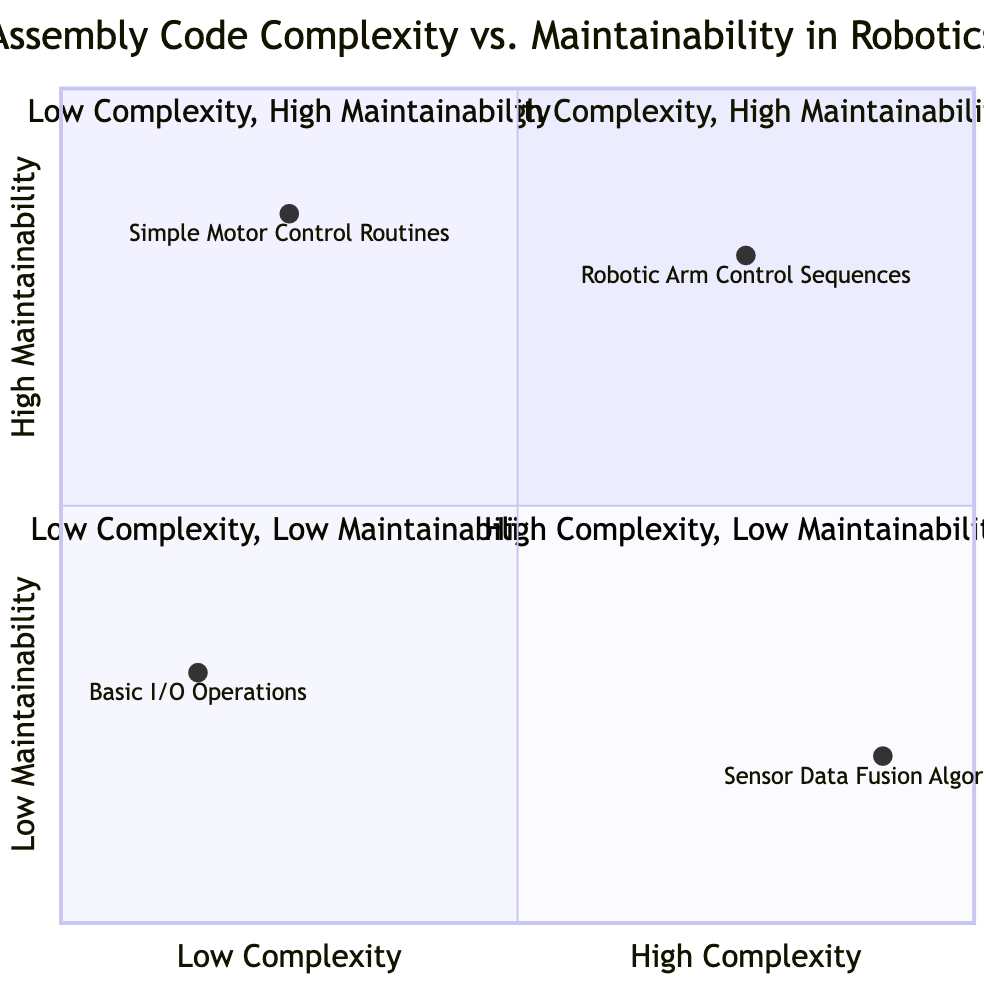What is the element in the High Complexity - High Maintainability quadrant? In the diagram, the High Complexity - High Maintainability quadrant lists "Robotic Arm Control Sequences" as the only element.
Answer: Robotic Arm Control Sequences How many elements are in the Low Complexity - Low Maintainability quadrant? The diagram shows that there is one element listed in the Low Complexity - Low Maintainability quadrant, which is "Basic I/O Operations."
Answer: One Which element has the highest complexity rating? From the diagram, the "Sensor Data Fusion Algorithms" is positioned in the High Complexity - Low Maintainability quadrant, representing the highest complexity.
Answer: Sensor Data Fusion Algorithms What is the maintainability rating of "Simple Motor Control Routines"? In the diagram, "Simple Motor Control Routines" is located in the Low Complexity - High Maintainability quadrant, indicating that it has a maintainability rating of 0.85.
Answer: 0.85 How does the maintainability of "Robotic Arm Control Sequences" compare to "Sensor Data Fusion Algorithms"? The maintainability rating of "Robotic Arm Control Sequences" is 0.80, while "Sensor Data Fusion Algorithms" has a maintainability rating of 0.20. This indicates that "Robotic Arm Control Sequences" is significantly more maintainable than "Sensor Data Fusion Algorithms."
Answer: Higher What element has the lowest maintainability rating? According to the data presented in the diagram, "Basic I/O Operations" has the lowest maintainability rating of 0.30.
Answer: Basic I/O Operations Which quadrant contains elements with both high complexity and low maintainability? The High Complexity - Low Maintainability quadrant contains "Sensor Data Fusion Algorithms," indicating this is the quadrant that corresponds to elements with both high complexity and low maintainability.
Answer: High Complexity - Low Maintainability What is the X-axis value for "Simple Motor Control Routines"? The diagram specifies the X-axis value for "Simple Motor Control Routines" as 0.25, representing its position on the complexity scale.
Answer: 0.25 Which quadrant represents elements that are easy to maintain but low in complexity? The Low Complexity - High Maintainability quadrant includes elements that are easy to maintain but low in complexity, specifically showing "Simple Motor Control Routines."
Answer: Low Complexity - High Maintainability 